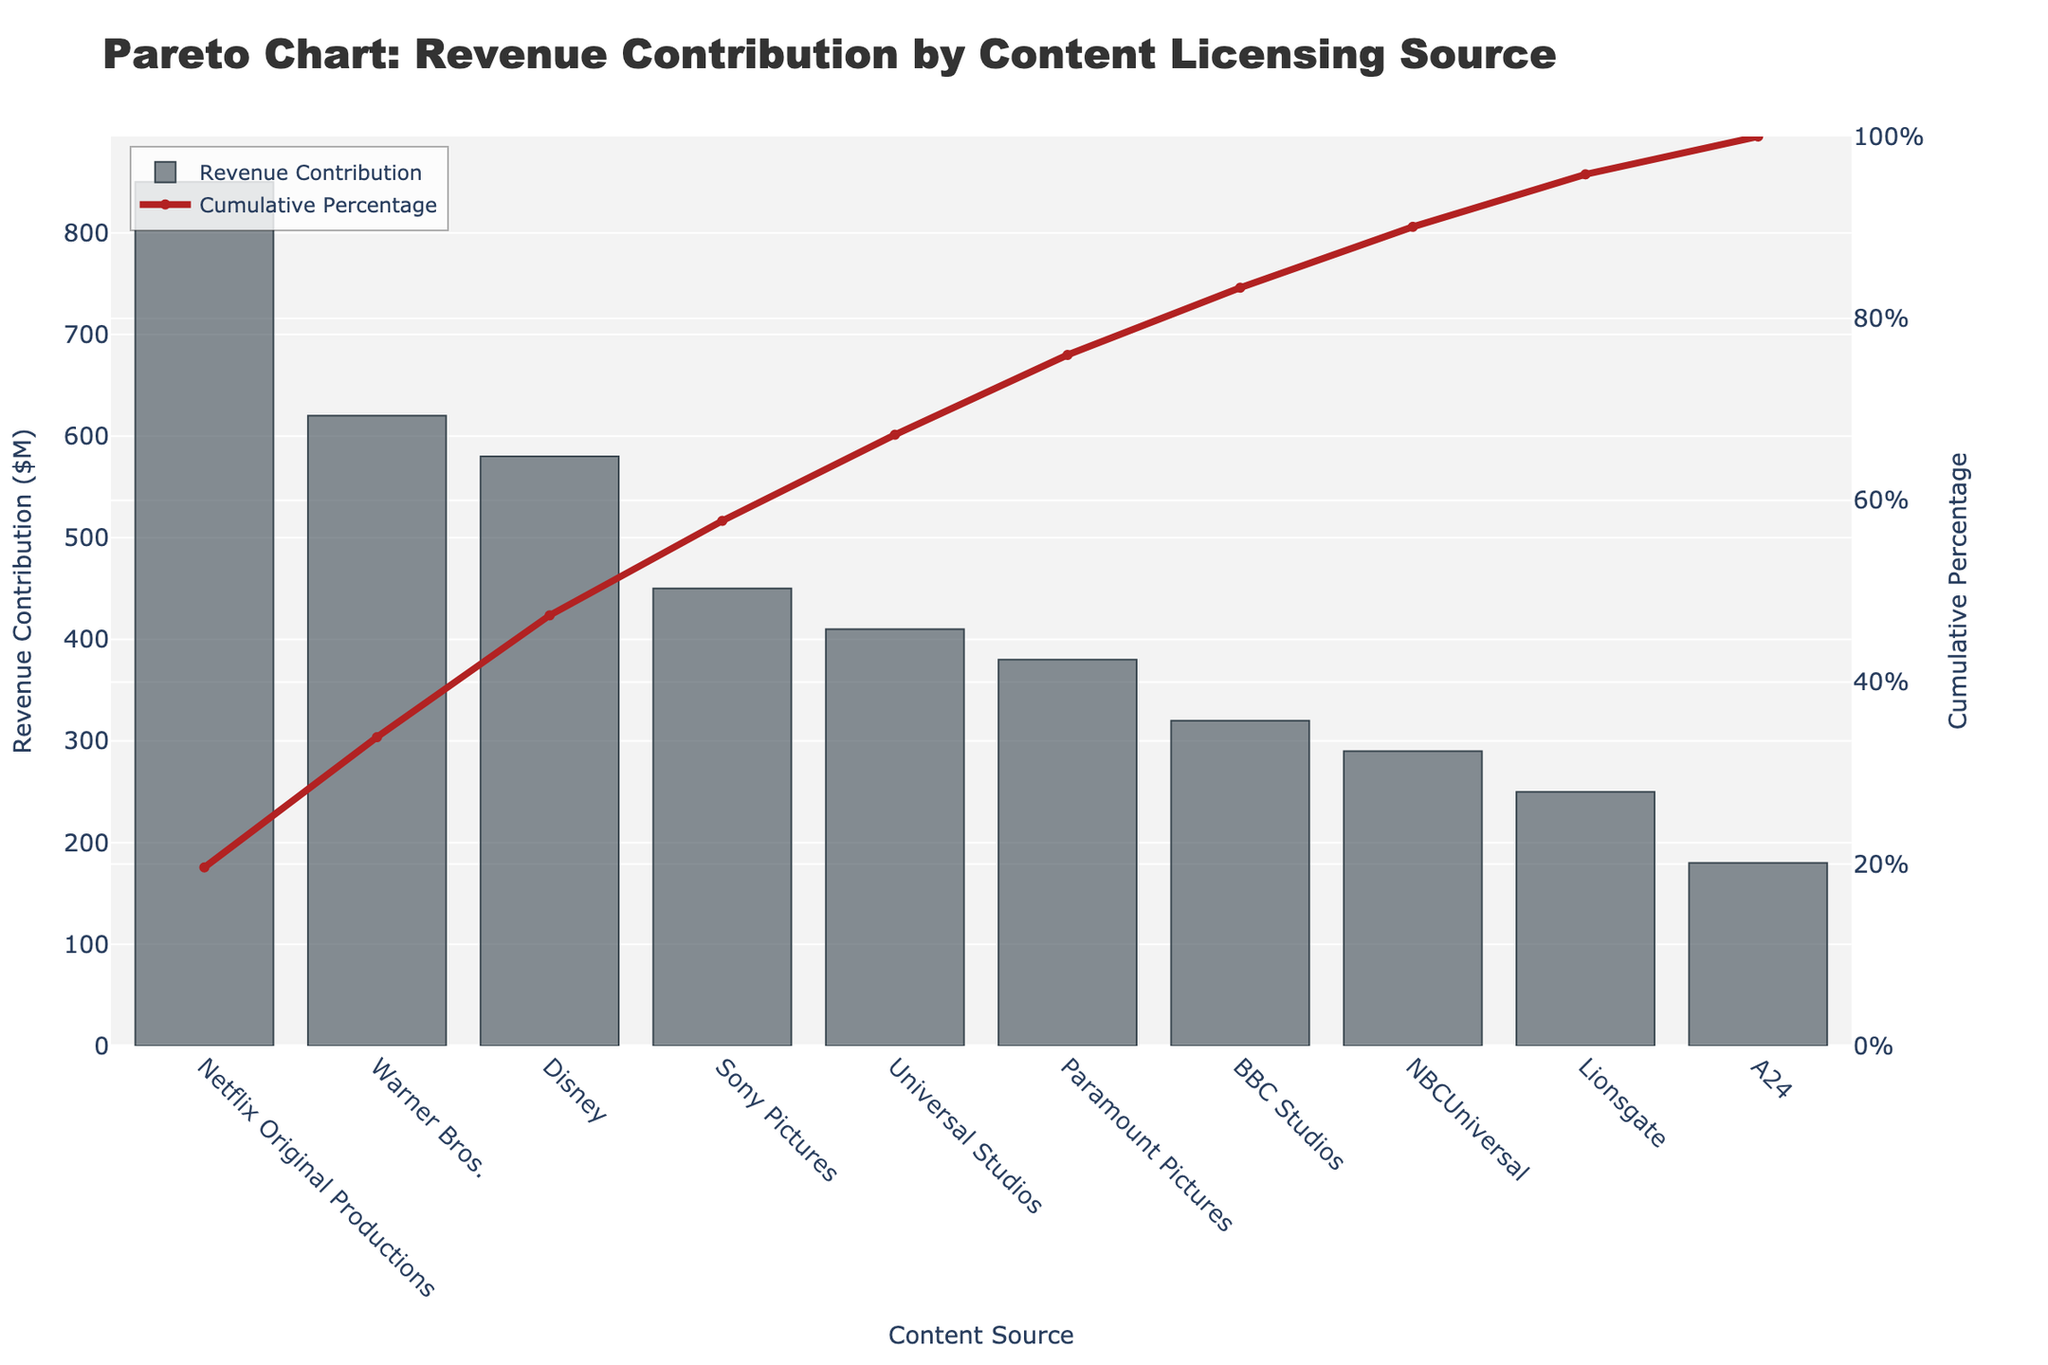What's the title of the figure? The title of the figure is displayed at the top. It reads "Pareto Chart: Revenue Contribution by Content Licensing Source".
Answer: Pareto Chart: Revenue Contribution by Content Licensing Source What revenue contribution does Netflix Original Productions have? The bar representing Netflix Original Productions is the first and highest bar on the chart. The y-axis on the left shows the revenue contribution in million dollars, which is $850M.
Answer: $850M What is the cumulative percentage of the revenue contributed by Warner Bros.? The line chart shows the cumulative percentage. For Warner Bros., which is the second bar, the cumulative percentage looks to be around 48%.
Answer: ~48% How many content sources contribute revenue to the chart? The x-axis labels the content sources. Counting these labels gives us a total of 10 content sources.
Answer: 10 Which content source contributes the least revenue? The shortest bar on the chart represents A24, indicating it contributes the least revenue.
Answer: A24 What is the cumulative revenue contribution percentage for the top three content sources? By following the line chart on the secondary y-axis: Netflix Original Productions, Warner Bros., and Disney give us a cumulative percentage around 75%.
Answer: ~75% By what percentage does Disney contribute to the total cumulative revenue up to its point? Disney is the third bar. Following the line, it intersects the cumulative percentage axis at around 69%.
Answer: ~69% Compare the revenue contributions between NBCUniversal and Lionsgate. Which one is higher? The bar for NBCUniversal is higher compared to Lionsgate, indicating that NBCUniversal has a higher revenue contribution ($290M vs. $250M).
Answer: NBCUniversal How much total revenue is contributed by Universal Studios, Paramount Pictures, and BBC Studios combined? Add the values for Universal Studios ($410M), Paramount Pictures ($380M), and BBC Studios ($320M): 410 + 380 + 320 = 1110.
Answer: $1110M What's the combined cumulative percentage of revenue contribution for Universal Studios and all higher revenue sources? The cumulative percentage line for Universal Studios intersects around the 93% mark.
Answer: ~93% 